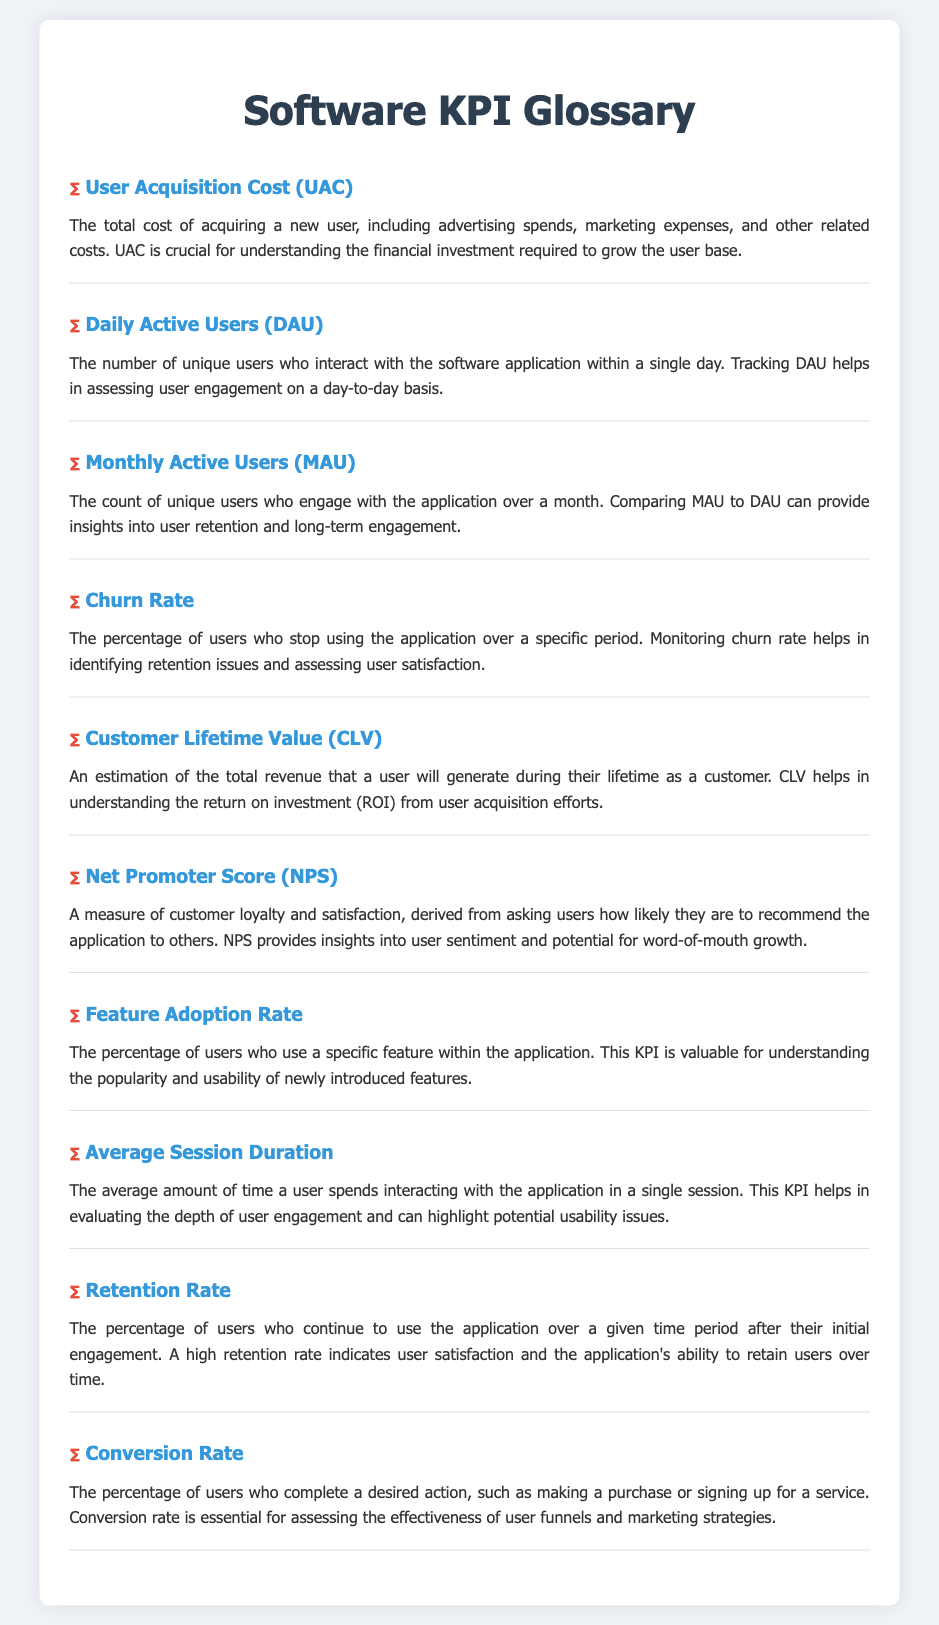what is User Acquisition Cost? User Acquisition Cost (UAC) is defined as the total cost of acquiring a new user, including advertising spends and marketing expenses.
Answer: total cost of acquiring a new user how many Daily Active Users are tracked? The glossary defines Daily Active Users (DAU) as the number of unique users who interact with the software application within a single day.
Answer: unique users interacting daily what does Churn Rate measure? Churn Rate measures the percentage of users who stop using the application over a specific period.
Answer: percentage of users who stop using the application what is Customer Lifetime Value? Customer Lifetime Value (CLV) is defined as an estimation of the total revenue that a user will generate during their lifetime as a customer.
Answer: total revenue generated during their lifetime what insight does Net Promoter Score provide? Net Promoter Score (NPS) provides insights into customer loyalty and satisfaction based on how likely users are to recommend the application.
Answer: insights into customer loyalty and satisfaction what is the definition of Retention Rate? Retention Rate is the percentage of users who continue to use the application over a given time period after their initial engagement.
Answer: percentage of users who continue to use the application which KPI helps to evaluate feature usability? Feature Adoption Rate is the KPI that assists in understanding the popularity and usability of newly introduced features.
Answer: Feature Adoption Rate how is Conversion Rate calculated? Conversion Rate is calculated as the percentage of users who complete a desired action, like making a purchase or signing up for a service.
Answer: percentage of users who complete a desired action 